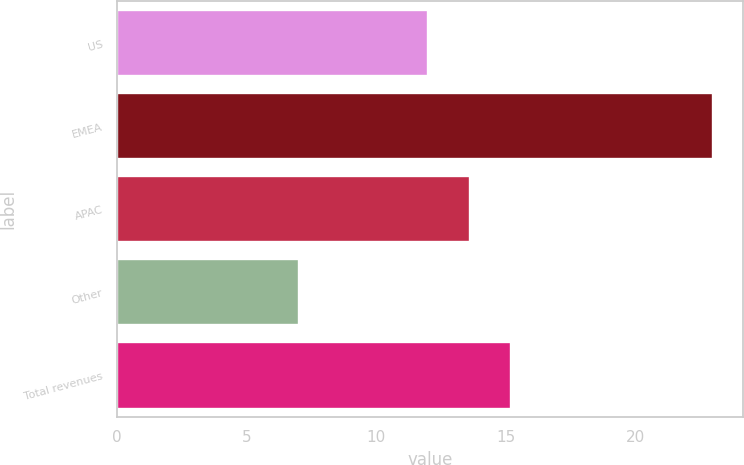<chart> <loc_0><loc_0><loc_500><loc_500><bar_chart><fcel>US<fcel>EMEA<fcel>APAC<fcel>Other<fcel>Total revenues<nl><fcel>12<fcel>23<fcel>13.6<fcel>7<fcel>15.2<nl></chart> 